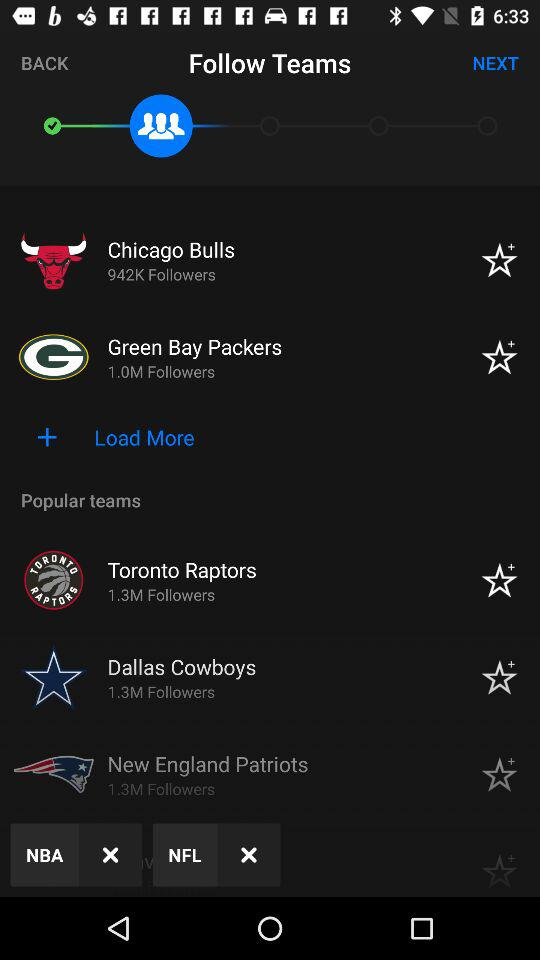What is the number of followers of the "Green Bay Packers"? The number of followers is 1 million. 